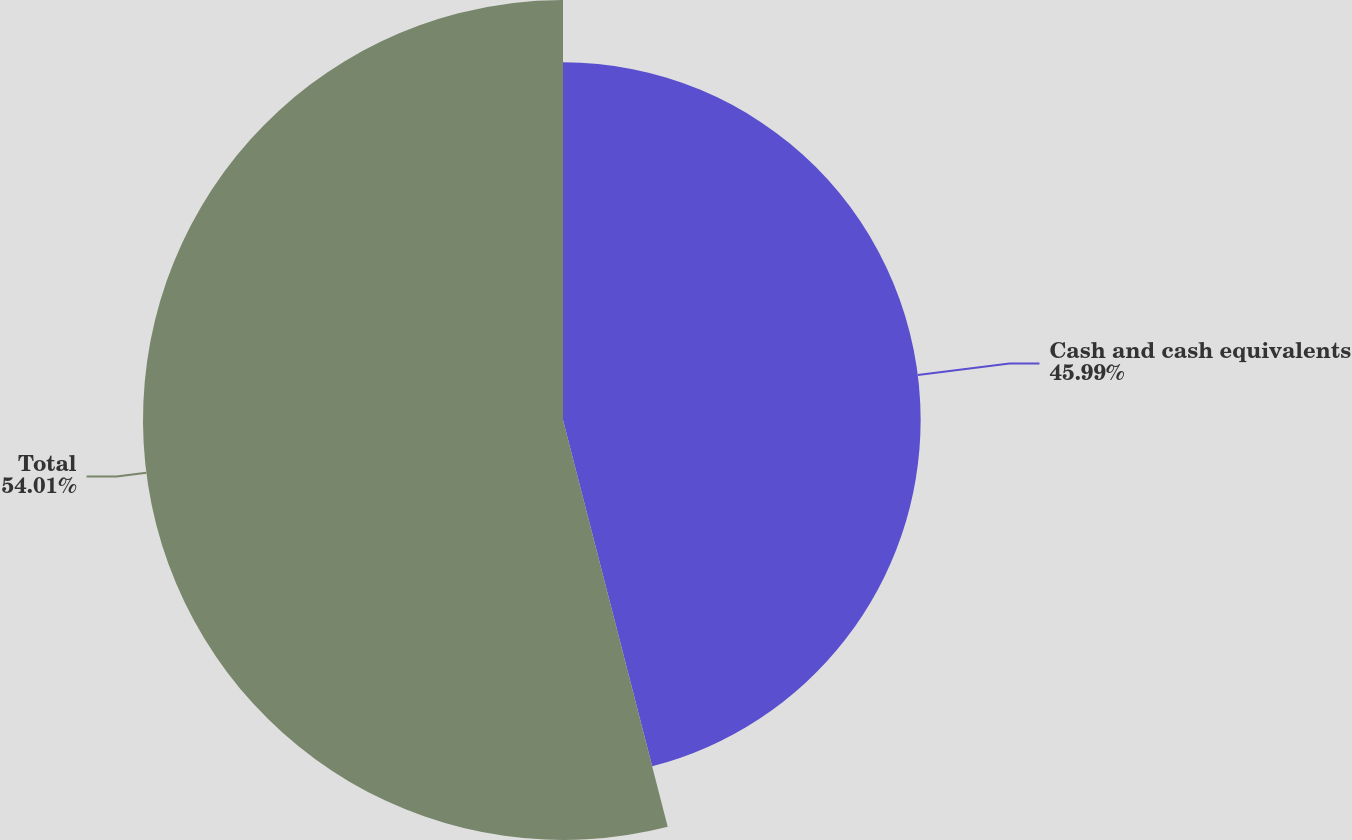Convert chart to OTSL. <chart><loc_0><loc_0><loc_500><loc_500><pie_chart><fcel>Cash and cash equivalents<fcel>Total<nl><fcel>45.99%<fcel>54.01%<nl></chart> 